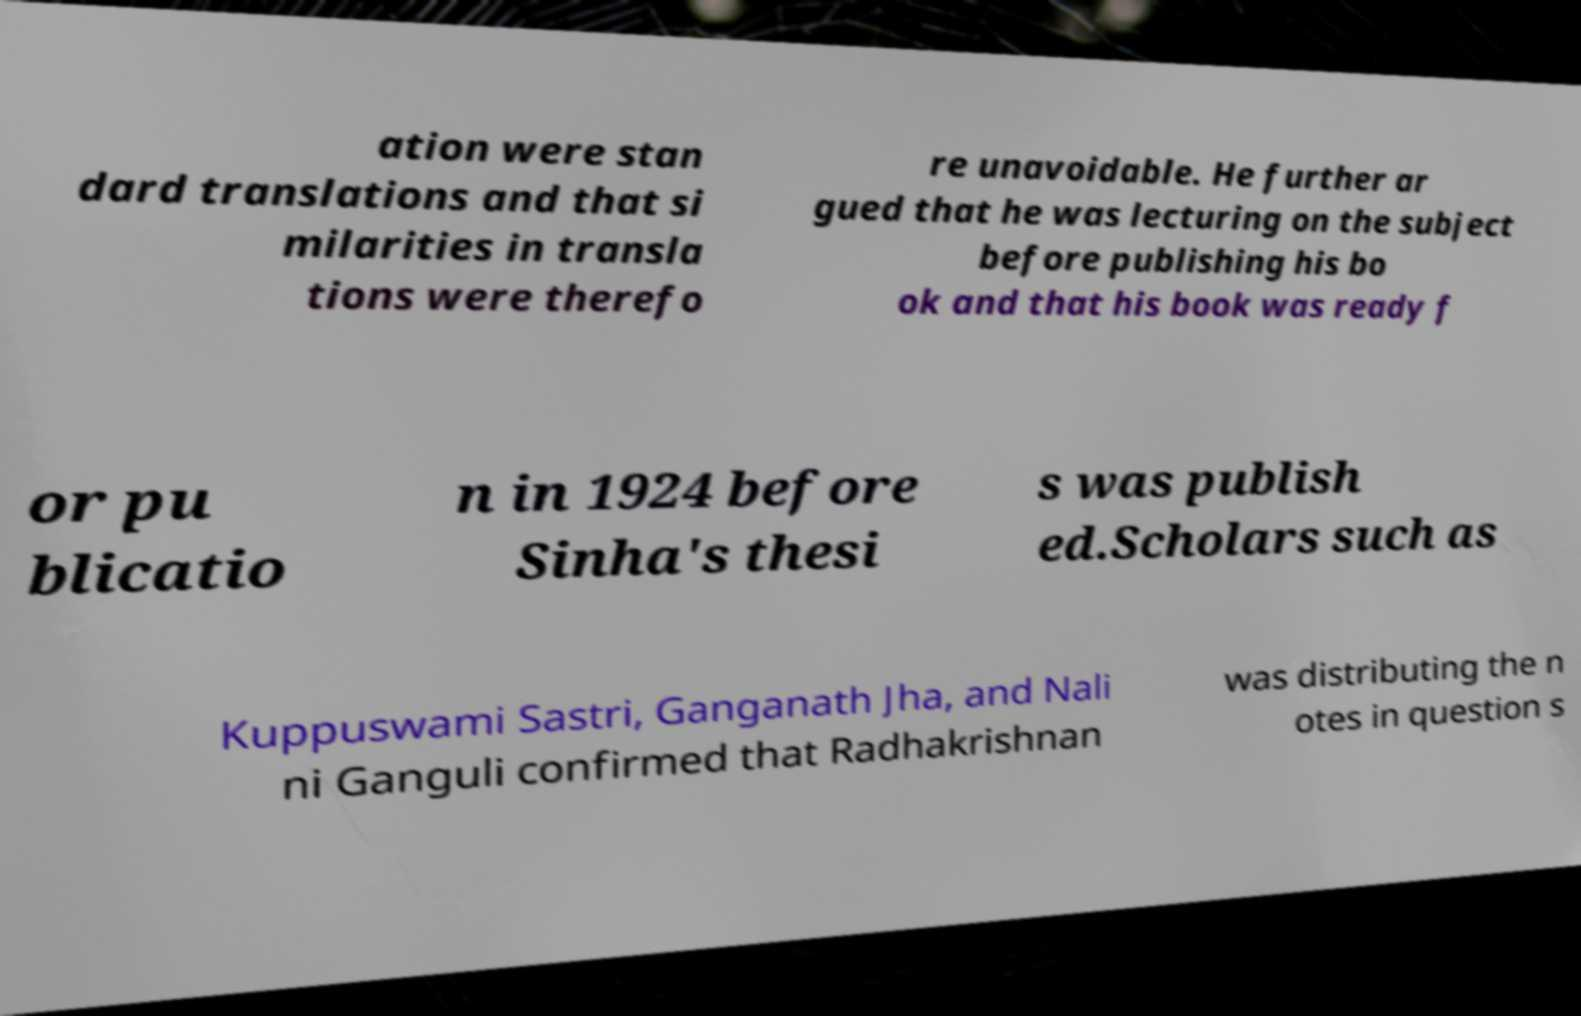Can you read and provide the text displayed in the image?This photo seems to have some interesting text. Can you extract and type it out for me? ation were stan dard translations and that si milarities in transla tions were therefo re unavoidable. He further ar gued that he was lecturing on the subject before publishing his bo ok and that his book was ready f or pu blicatio n in 1924 before Sinha's thesi s was publish ed.Scholars such as Kuppuswami Sastri, Ganganath Jha, and Nali ni Ganguli confirmed that Radhakrishnan was distributing the n otes in question s 